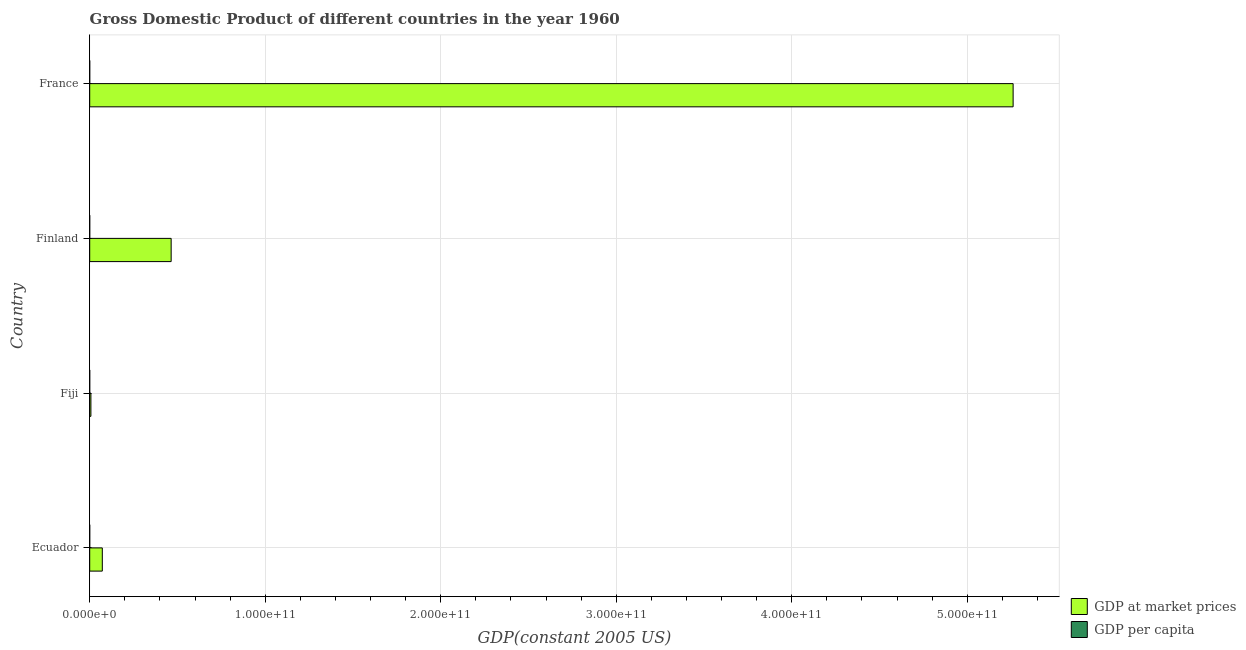How many different coloured bars are there?
Make the answer very short. 2. How many groups of bars are there?
Provide a short and direct response. 4. Are the number of bars on each tick of the Y-axis equal?
Your answer should be compact. Yes. How many bars are there on the 4th tick from the top?
Provide a short and direct response. 2. What is the label of the 1st group of bars from the top?
Provide a succinct answer. France. What is the gdp per capita in Fiji?
Keep it short and to the point. 1759.58. Across all countries, what is the maximum gdp at market prices?
Your answer should be compact. 5.26e+11. Across all countries, what is the minimum gdp at market prices?
Ensure brevity in your answer.  6.92e+08. In which country was the gdp at market prices maximum?
Your answer should be very brief. France. In which country was the gdp at market prices minimum?
Ensure brevity in your answer.  Fiji. What is the total gdp at market prices in the graph?
Offer a terse response. 5.80e+11. What is the difference between the gdp per capita in Fiji and that in France?
Ensure brevity in your answer.  -9479.7. What is the difference between the gdp per capita in Ecuador and the gdp at market prices in Finland?
Keep it short and to the point. -4.64e+1. What is the average gdp at market prices per country?
Provide a short and direct response. 1.45e+11. What is the difference between the gdp at market prices and gdp per capita in France?
Make the answer very short. 5.26e+11. In how many countries, is the gdp per capita greater than 360000000000 US$?
Your answer should be compact. 0. What is the ratio of the gdp at market prices in Ecuador to that in Finland?
Offer a terse response. 0.15. Is the gdp at market prices in Fiji less than that in Finland?
Offer a very short reply. Yes. What is the difference between the highest and the second highest gdp at market prices?
Your answer should be very brief. 4.80e+11. What is the difference between the highest and the lowest gdp at market prices?
Offer a very short reply. 5.25e+11. Is the sum of the gdp per capita in Ecuador and Finland greater than the maximum gdp at market prices across all countries?
Your answer should be very brief. No. What does the 1st bar from the top in Fiji represents?
Keep it short and to the point. GDP per capita. What does the 2nd bar from the bottom in Finland represents?
Give a very brief answer. GDP per capita. Are all the bars in the graph horizontal?
Your answer should be compact. Yes. What is the difference between two consecutive major ticks on the X-axis?
Provide a succinct answer. 1.00e+11. Are the values on the major ticks of X-axis written in scientific E-notation?
Keep it short and to the point. Yes. How many legend labels are there?
Your answer should be compact. 2. How are the legend labels stacked?
Provide a short and direct response. Vertical. What is the title of the graph?
Make the answer very short. Gross Domestic Product of different countries in the year 1960. What is the label or title of the X-axis?
Your response must be concise. GDP(constant 2005 US). What is the GDP(constant 2005 US) of GDP at market prices in Ecuador?
Make the answer very short. 7.19e+09. What is the GDP(constant 2005 US) of GDP per capita in Ecuador?
Your answer should be compact. 1582.31. What is the GDP(constant 2005 US) of GDP at market prices in Fiji?
Keep it short and to the point. 6.92e+08. What is the GDP(constant 2005 US) of GDP per capita in Fiji?
Your answer should be very brief. 1759.58. What is the GDP(constant 2005 US) in GDP at market prices in Finland?
Give a very brief answer. 4.64e+1. What is the GDP(constant 2005 US) in GDP per capita in Finland?
Give a very brief answer. 1.05e+04. What is the GDP(constant 2005 US) of GDP at market prices in France?
Your response must be concise. 5.26e+11. What is the GDP(constant 2005 US) in GDP per capita in France?
Your answer should be compact. 1.12e+04. Across all countries, what is the maximum GDP(constant 2005 US) in GDP at market prices?
Ensure brevity in your answer.  5.26e+11. Across all countries, what is the maximum GDP(constant 2005 US) in GDP per capita?
Your response must be concise. 1.12e+04. Across all countries, what is the minimum GDP(constant 2005 US) in GDP at market prices?
Offer a terse response. 6.92e+08. Across all countries, what is the minimum GDP(constant 2005 US) in GDP per capita?
Your answer should be compact. 1582.31. What is the total GDP(constant 2005 US) of GDP at market prices in the graph?
Provide a short and direct response. 5.80e+11. What is the total GDP(constant 2005 US) in GDP per capita in the graph?
Your response must be concise. 2.51e+04. What is the difference between the GDP(constant 2005 US) of GDP at market prices in Ecuador and that in Fiji?
Provide a succinct answer. 6.50e+09. What is the difference between the GDP(constant 2005 US) in GDP per capita in Ecuador and that in Fiji?
Provide a succinct answer. -177.27. What is the difference between the GDP(constant 2005 US) in GDP at market prices in Ecuador and that in Finland?
Ensure brevity in your answer.  -3.92e+1. What is the difference between the GDP(constant 2005 US) of GDP per capita in Ecuador and that in Finland?
Your answer should be compact. -8896.36. What is the difference between the GDP(constant 2005 US) in GDP at market prices in Ecuador and that in France?
Provide a succinct answer. -5.19e+11. What is the difference between the GDP(constant 2005 US) of GDP per capita in Ecuador and that in France?
Provide a succinct answer. -9656.97. What is the difference between the GDP(constant 2005 US) in GDP at market prices in Fiji and that in Finland?
Ensure brevity in your answer.  -4.57e+1. What is the difference between the GDP(constant 2005 US) in GDP per capita in Fiji and that in Finland?
Keep it short and to the point. -8719.09. What is the difference between the GDP(constant 2005 US) in GDP at market prices in Fiji and that in France?
Provide a short and direct response. -5.25e+11. What is the difference between the GDP(constant 2005 US) of GDP per capita in Fiji and that in France?
Offer a terse response. -9479.7. What is the difference between the GDP(constant 2005 US) of GDP at market prices in Finland and that in France?
Make the answer very short. -4.80e+11. What is the difference between the GDP(constant 2005 US) of GDP per capita in Finland and that in France?
Offer a terse response. -760.61. What is the difference between the GDP(constant 2005 US) of GDP at market prices in Ecuador and the GDP(constant 2005 US) of GDP per capita in Fiji?
Ensure brevity in your answer.  7.19e+09. What is the difference between the GDP(constant 2005 US) in GDP at market prices in Ecuador and the GDP(constant 2005 US) in GDP per capita in Finland?
Keep it short and to the point. 7.19e+09. What is the difference between the GDP(constant 2005 US) in GDP at market prices in Ecuador and the GDP(constant 2005 US) in GDP per capita in France?
Offer a very short reply. 7.19e+09. What is the difference between the GDP(constant 2005 US) of GDP at market prices in Fiji and the GDP(constant 2005 US) of GDP per capita in Finland?
Ensure brevity in your answer.  6.92e+08. What is the difference between the GDP(constant 2005 US) of GDP at market prices in Fiji and the GDP(constant 2005 US) of GDP per capita in France?
Keep it short and to the point. 6.92e+08. What is the difference between the GDP(constant 2005 US) in GDP at market prices in Finland and the GDP(constant 2005 US) in GDP per capita in France?
Ensure brevity in your answer.  4.64e+1. What is the average GDP(constant 2005 US) in GDP at market prices per country?
Your answer should be very brief. 1.45e+11. What is the average GDP(constant 2005 US) of GDP per capita per country?
Provide a short and direct response. 6264.96. What is the difference between the GDP(constant 2005 US) in GDP at market prices and GDP(constant 2005 US) in GDP per capita in Ecuador?
Offer a terse response. 7.19e+09. What is the difference between the GDP(constant 2005 US) of GDP at market prices and GDP(constant 2005 US) of GDP per capita in Fiji?
Offer a very short reply. 6.92e+08. What is the difference between the GDP(constant 2005 US) in GDP at market prices and GDP(constant 2005 US) in GDP per capita in Finland?
Give a very brief answer. 4.64e+1. What is the difference between the GDP(constant 2005 US) of GDP at market prices and GDP(constant 2005 US) of GDP per capita in France?
Your response must be concise. 5.26e+11. What is the ratio of the GDP(constant 2005 US) of GDP at market prices in Ecuador to that in Fiji?
Ensure brevity in your answer.  10.39. What is the ratio of the GDP(constant 2005 US) in GDP per capita in Ecuador to that in Fiji?
Your response must be concise. 0.9. What is the ratio of the GDP(constant 2005 US) in GDP at market prices in Ecuador to that in Finland?
Keep it short and to the point. 0.15. What is the ratio of the GDP(constant 2005 US) of GDP per capita in Ecuador to that in Finland?
Your answer should be compact. 0.15. What is the ratio of the GDP(constant 2005 US) of GDP at market prices in Ecuador to that in France?
Provide a short and direct response. 0.01. What is the ratio of the GDP(constant 2005 US) of GDP per capita in Ecuador to that in France?
Offer a very short reply. 0.14. What is the ratio of the GDP(constant 2005 US) in GDP at market prices in Fiji to that in Finland?
Make the answer very short. 0.01. What is the ratio of the GDP(constant 2005 US) of GDP per capita in Fiji to that in Finland?
Make the answer very short. 0.17. What is the ratio of the GDP(constant 2005 US) in GDP at market prices in Fiji to that in France?
Ensure brevity in your answer.  0. What is the ratio of the GDP(constant 2005 US) of GDP per capita in Fiji to that in France?
Give a very brief answer. 0.16. What is the ratio of the GDP(constant 2005 US) in GDP at market prices in Finland to that in France?
Ensure brevity in your answer.  0.09. What is the ratio of the GDP(constant 2005 US) of GDP per capita in Finland to that in France?
Ensure brevity in your answer.  0.93. What is the difference between the highest and the second highest GDP(constant 2005 US) in GDP at market prices?
Your response must be concise. 4.80e+11. What is the difference between the highest and the second highest GDP(constant 2005 US) of GDP per capita?
Give a very brief answer. 760.61. What is the difference between the highest and the lowest GDP(constant 2005 US) of GDP at market prices?
Your response must be concise. 5.25e+11. What is the difference between the highest and the lowest GDP(constant 2005 US) in GDP per capita?
Your answer should be very brief. 9656.97. 